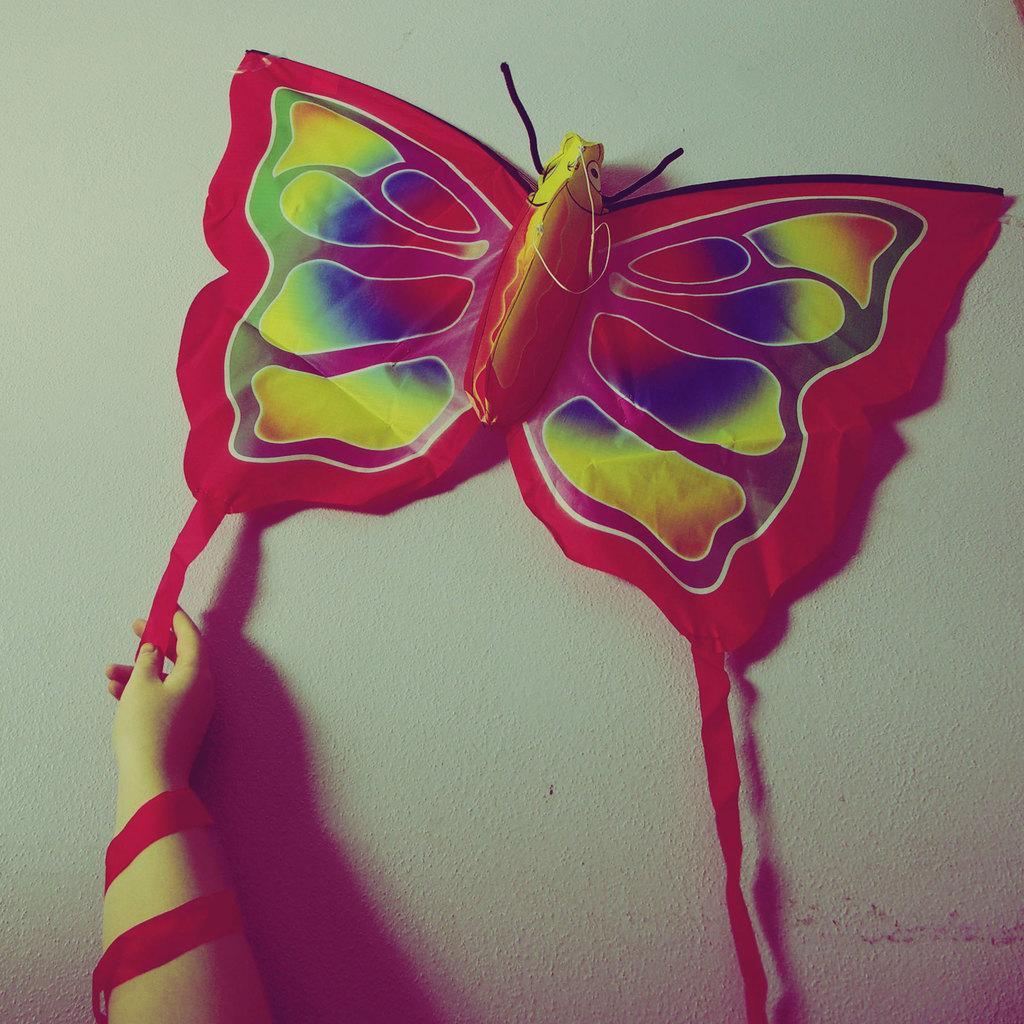Describe this image in one or two sentences. In this image I can see a butterfly shaped object on a wall. Here I can see a person's hand. 